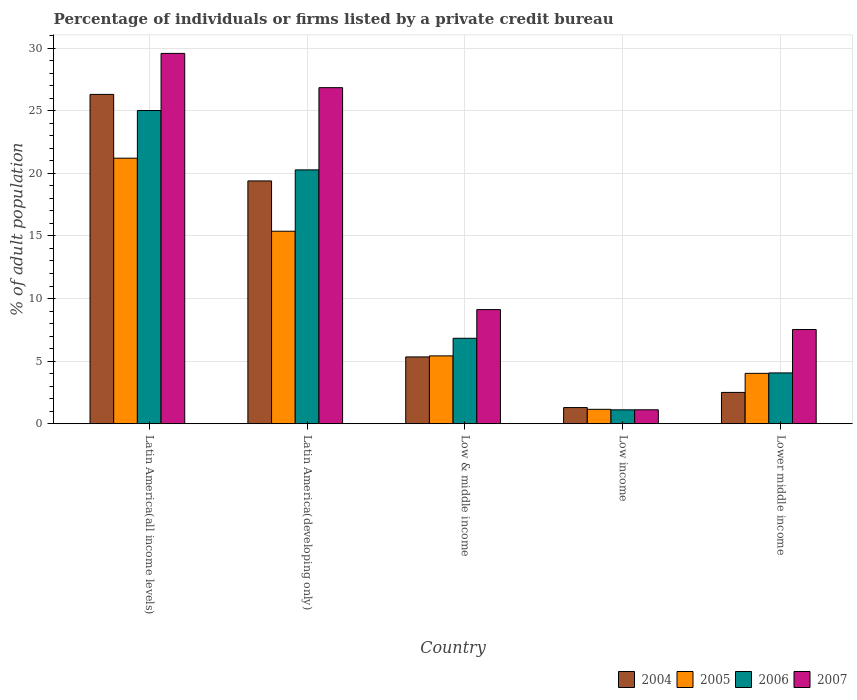How many groups of bars are there?
Your answer should be very brief. 5. Are the number of bars on each tick of the X-axis equal?
Your response must be concise. Yes. How many bars are there on the 2nd tick from the right?
Offer a very short reply. 4. What is the label of the 2nd group of bars from the left?
Keep it short and to the point. Latin America(developing only). In how many cases, is the number of bars for a given country not equal to the number of legend labels?
Make the answer very short. 0. What is the percentage of population listed by a private credit bureau in 2006 in Lower middle income?
Your answer should be compact. 4.06. Across all countries, what is the maximum percentage of population listed by a private credit bureau in 2004?
Make the answer very short. 26.3. Across all countries, what is the minimum percentage of population listed by a private credit bureau in 2007?
Keep it short and to the point. 1.11. In which country was the percentage of population listed by a private credit bureau in 2006 maximum?
Provide a short and direct response. Latin America(all income levels). In which country was the percentage of population listed by a private credit bureau in 2007 minimum?
Provide a succinct answer. Low income. What is the total percentage of population listed by a private credit bureau in 2006 in the graph?
Your response must be concise. 57.29. What is the difference between the percentage of population listed by a private credit bureau in 2007 in Latin America(developing only) and that in Lower middle income?
Provide a short and direct response. 19.32. What is the difference between the percentage of population listed by a private credit bureau in 2006 in Latin America(all income levels) and the percentage of population listed by a private credit bureau in 2005 in Latin America(developing only)?
Ensure brevity in your answer.  9.64. What is the average percentage of population listed by a private credit bureau in 2004 per country?
Provide a succinct answer. 10.97. What is the difference between the percentage of population listed by a private credit bureau of/in 2006 and percentage of population listed by a private credit bureau of/in 2007 in Low income?
Your answer should be compact. -0. In how many countries, is the percentage of population listed by a private credit bureau in 2007 greater than 18 %?
Offer a very short reply. 2. What is the ratio of the percentage of population listed by a private credit bureau in 2007 in Low income to that in Lower middle income?
Ensure brevity in your answer.  0.15. Is the percentage of population listed by a private credit bureau in 2004 in Latin America(all income levels) less than that in Low income?
Keep it short and to the point. No. Is the difference between the percentage of population listed by a private credit bureau in 2006 in Latin America(all income levels) and Latin America(developing only) greater than the difference between the percentage of population listed by a private credit bureau in 2007 in Latin America(all income levels) and Latin America(developing only)?
Ensure brevity in your answer.  Yes. What is the difference between the highest and the second highest percentage of population listed by a private credit bureau in 2007?
Offer a very short reply. -17.73. What is the difference between the highest and the lowest percentage of population listed by a private credit bureau in 2005?
Ensure brevity in your answer.  20.06. In how many countries, is the percentage of population listed by a private credit bureau in 2007 greater than the average percentage of population listed by a private credit bureau in 2007 taken over all countries?
Provide a short and direct response. 2. Is the sum of the percentage of population listed by a private credit bureau in 2005 in Latin America(all income levels) and Lower middle income greater than the maximum percentage of population listed by a private credit bureau in 2007 across all countries?
Provide a succinct answer. No. What does the 3rd bar from the left in Low income represents?
Keep it short and to the point. 2006. How many countries are there in the graph?
Provide a succinct answer. 5. What is the difference between two consecutive major ticks on the Y-axis?
Your answer should be compact. 5. Are the values on the major ticks of Y-axis written in scientific E-notation?
Give a very brief answer. No. Does the graph contain any zero values?
Provide a short and direct response. No. Does the graph contain grids?
Offer a terse response. Yes. Where does the legend appear in the graph?
Offer a terse response. Bottom right. How many legend labels are there?
Provide a succinct answer. 4. How are the legend labels stacked?
Give a very brief answer. Horizontal. What is the title of the graph?
Your answer should be very brief. Percentage of individuals or firms listed by a private credit bureau. Does "2002" appear as one of the legend labels in the graph?
Provide a short and direct response. No. What is the label or title of the X-axis?
Make the answer very short. Country. What is the label or title of the Y-axis?
Give a very brief answer. % of adult population. What is the % of adult population of 2004 in Latin America(all income levels)?
Offer a very short reply. 26.3. What is the % of adult population in 2005 in Latin America(all income levels)?
Offer a terse response. 21.21. What is the % of adult population in 2006 in Latin America(all income levels)?
Make the answer very short. 25.02. What is the % of adult population of 2007 in Latin America(all income levels)?
Provide a short and direct response. 29.58. What is the % of adult population in 2004 in Latin America(developing only)?
Provide a short and direct response. 19.39. What is the % of adult population of 2005 in Latin America(developing only)?
Make the answer very short. 15.38. What is the % of adult population in 2006 in Latin America(developing only)?
Offer a very short reply. 20.28. What is the % of adult population of 2007 in Latin America(developing only)?
Provide a short and direct response. 26.84. What is the % of adult population in 2004 in Low & middle income?
Provide a short and direct response. 5.34. What is the % of adult population of 2005 in Low & middle income?
Ensure brevity in your answer.  5.42. What is the % of adult population of 2006 in Low & middle income?
Keep it short and to the point. 6.83. What is the % of adult population of 2007 in Low & middle income?
Ensure brevity in your answer.  9.12. What is the % of adult population of 2004 in Low income?
Provide a short and direct response. 1.29. What is the % of adult population of 2005 in Low income?
Offer a terse response. 1.15. What is the % of adult population of 2006 in Low income?
Provide a succinct answer. 1.11. What is the % of adult population in 2007 in Low income?
Provide a succinct answer. 1.11. What is the % of adult population in 2004 in Lower middle income?
Offer a very short reply. 2.5. What is the % of adult population in 2005 in Lower middle income?
Keep it short and to the point. 4.03. What is the % of adult population in 2006 in Lower middle income?
Your response must be concise. 4.06. What is the % of adult population in 2007 in Lower middle income?
Provide a short and direct response. 7.53. Across all countries, what is the maximum % of adult population in 2004?
Your answer should be compact. 26.3. Across all countries, what is the maximum % of adult population of 2005?
Offer a very short reply. 21.21. Across all countries, what is the maximum % of adult population of 2006?
Offer a very short reply. 25.02. Across all countries, what is the maximum % of adult population of 2007?
Ensure brevity in your answer.  29.58. Across all countries, what is the minimum % of adult population of 2004?
Give a very brief answer. 1.29. Across all countries, what is the minimum % of adult population of 2005?
Offer a terse response. 1.15. Across all countries, what is the minimum % of adult population of 2006?
Make the answer very short. 1.11. Across all countries, what is the minimum % of adult population of 2007?
Give a very brief answer. 1.11. What is the total % of adult population of 2004 in the graph?
Offer a very short reply. 54.83. What is the total % of adult population in 2005 in the graph?
Your answer should be compact. 47.18. What is the total % of adult population in 2006 in the graph?
Ensure brevity in your answer.  57.29. What is the total % of adult population in 2007 in the graph?
Offer a terse response. 74.18. What is the difference between the % of adult population in 2004 in Latin America(all income levels) and that in Latin America(developing only)?
Provide a succinct answer. 6.91. What is the difference between the % of adult population in 2005 in Latin America(all income levels) and that in Latin America(developing only)?
Offer a very short reply. 5.83. What is the difference between the % of adult population of 2006 in Latin America(all income levels) and that in Latin America(developing only)?
Provide a short and direct response. 4.74. What is the difference between the % of adult population in 2007 in Latin America(all income levels) and that in Latin America(developing only)?
Offer a very short reply. 2.74. What is the difference between the % of adult population of 2004 in Latin America(all income levels) and that in Low & middle income?
Your response must be concise. 20.97. What is the difference between the % of adult population in 2005 in Latin America(all income levels) and that in Low & middle income?
Provide a short and direct response. 15.79. What is the difference between the % of adult population of 2006 in Latin America(all income levels) and that in Low & middle income?
Offer a very short reply. 18.19. What is the difference between the % of adult population of 2007 in Latin America(all income levels) and that in Low & middle income?
Ensure brevity in your answer.  20.46. What is the difference between the % of adult population of 2004 in Latin America(all income levels) and that in Low income?
Offer a very short reply. 25.01. What is the difference between the % of adult population of 2005 in Latin America(all income levels) and that in Low income?
Your answer should be compact. 20.06. What is the difference between the % of adult population of 2006 in Latin America(all income levels) and that in Low income?
Offer a very short reply. 23.91. What is the difference between the % of adult population of 2007 in Latin America(all income levels) and that in Low income?
Keep it short and to the point. 28.47. What is the difference between the % of adult population of 2004 in Latin America(all income levels) and that in Lower middle income?
Your answer should be compact. 23.8. What is the difference between the % of adult population of 2005 in Latin America(all income levels) and that in Lower middle income?
Ensure brevity in your answer.  17.19. What is the difference between the % of adult population in 2006 in Latin America(all income levels) and that in Lower middle income?
Keep it short and to the point. 20.96. What is the difference between the % of adult population in 2007 in Latin America(all income levels) and that in Lower middle income?
Keep it short and to the point. 22.05. What is the difference between the % of adult population in 2004 in Latin America(developing only) and that in Low & middle income?
Make the answer very short. 14.06. What is the difference between the % of adult population in 2005 in Latin America(developing only) and that in Low & middle income?
Provide a succinct answer. 9.96. What is the difference between the % of adult population in 2006 in Latin America(developing only) and that in Low & middle income?
Your answer should be compact. 13.45. What is the difference between the % of adult population in 2007 in Latin America(developing only) and that in Low & middle income?
Keep it short and to the point. 17.73. What is the difference between the % of adult population in 2004 in Latin America(developing only) and that in Low income?
Provide a short and direct response. 18.1. What is the difference between the % of adult population in 2005 in Latin America(developing only) and that in Low income?
Offer a terse response. 14.22. What is the difference between the % of adult population in 2006 in Latin America(developing only) and that in Low income?
Ensure brevity in your answer.  19.17. What is the difference between the % of adult population of 2007 in Latin America(developing only) and that in Low income?
Ensure brevity in your answer.  25.73. What is the difference between the % of adult population in 2004 in Latin America(developing only) and that in Lower middle income?
Provide a succinct answer. 16.89. What is the difference between the % of adult population of 2005 in Latin America(developing only) and that in Lower middle income?
Give a very brief answer. 11.35. What is the difference between the % of adult population of 2006 in Latin America(developing only) and that in Lower middle income?
Offer a very short reply. 16.22. What is the difference between the % of adult population in 2007 in Latin America(developing only) and that in Lower middle income?
Your response must be concise. 19.32. What is the difference between the % of adult population in 2004 in Low & middle income and that in Low income?
Your response must be concise. 4.04. What is the difference between the % of adult population in 2005 in Low & middle income and that in Low income?
Provide a succinct answer. 4.27. What is the difference between the % of adult population in 2006 in Low & middle income and that in Low income?
Provide a short and direct response. 5.72. What is the difference between the % of adult population of 2007 in Low & middle income and that in Low income?
Offer a very short reply. 8. What is the difference between the % of adult population in 2004 in Low & middle income and that in Lower middle income?
Ensure brevity in your answer.  2.83. What is the difference between the % of adult population of 2005 in Low & middle income and that in Lower middle income?
Your answer should be very brief. 1.39. What is the difference between the % of adult population of 2006 in Low & middle income and that in Lower middle income?
Offer a very short reply. 2.77. What is the difference between the % of adult population of 2007 in Low & middle income and that in Lower middle income?
Your response must be concise. 1.59. What is the difference between the % of adult population of 2004 in Low income and that in Lower middle income?
Keep it short and to the point. -1.21. What is the difference between the % of adult population of 2005 in Low income and that in Lower middle income?
Offer a terse response. -2.87. What is the difference between the % of adult population of 2006 in Low income and that in Lower middle income?
Provide a short and direct response. -2.95. What is the difference between the % of adult population of 2007 in Low income and that in Lower middle income?
Provide a succinct answer. -6.41. What is the difference between the % of adult population of 2004 in Latin America(all income levels) and the % of adult population of 2005 in Latin America(developing only)?
Your response must be concise. 10.93. What is the difference between the % of adult population of 2004 in Latin America(all income levels) and the % of adult population of 2006 in Latin America(developing only)?
Offer a very short reply. 6.03. What is the difference between the % of adult population of 2004 in Latin America(all income levels) and the % of adult population of 2007 in Latin America(developing only)?
Provide a succinct answer. -0.54. What is the difference between the % of adult population of 2005 in Latin America(all income levels) and the % of adult population of 2006 in Latin America(developing only)?
Your answer should be very brief. 0.93. What is the difference between the % of adult population in 2005 in Latin America(all income levels) and the % of adult population in 2007 in Latin America(developing only)?
Offer a very short reply. -5.63. What is the difference between the % of adult population of 2006 in Latin America(all income levels) and the % of adult population of 2007 in Latin America(developing only)?
Provide a short and direct response. -1.83. What is the difference between the % of adult population of 2004 in Latin America(all income levels) and the % of adult population of 2005 in Low & middle income?
Offer a terse response. 20.89. What is the difference between the % of adult population of 2004 in Latin America(all income levels) and the % of adult population of 2006 in Low & middle income?
Provide a succinct answer. 19.48. What is the difference between the % of adult population of 2004 in Latin America(all income levels) and the % of adult population of 2007 in Low & middle income?
Offer a terse response. 17.19. What is the difference between the % of adult population of 2005 in Latin America(all income levels) and the % of adult population of 2006 in Low & middle income?
Your answer should be very brief. 14.38. What is the difference between the % of adult population in 2005 in Latin America(all income levels) and the % of adult population in 2007 in Low & middle income?
Your answer should be very brief. 12.09. What is the difference between the % of adult population in 2006 in Latin America(all income levels) and the % of adult population in 2007 in Low & middle income?
Make the answer very short. 15.9. What is the difference between the % of adult population in 2004 in Latin America(all income levels) and the % of adult population in 2005 in Low income?
Ensure brevity in your answer.  25.15. What is the difference between the % of adult population in 2004 in Latin America(all income levels) and the % of adult population in 2006 in Low income?
Ensure brevity in your answer.  25.19. What is the difference between the % of adult population in 2004 in Latin America(all income levels) and the % of adult population in 2007 in Low income?
Your response must be concise. 25.19. What is the difference between the % of adult population of 2005 in Latin America(all income levels) and the % of adult population of 2006 in Low income?
Provide a succinct answer. 20.1. What is the difference between the % of adult population of 2005 in Latin America(all income levels) and the % of adult population of 2007 in Low income?
Ensure brevity in your answer.  20.1. What is the difference between the % of adult population of 2006 in Latin America(all income levels) and the % of adult population of 2007 in Low income?
Offer a terse response. 23.9. What is the difference between the % of adult population in 2004 in Latin America(all income levels) and the % of adult population in 2005 in Lower middle income?
Provide a succinct answer. 22.28. What is the difference between the % of adult population of 2004 in Latin America(all income levels) and the % of adult population of 2006 in Lower middle income?
Your response must be concise. 22.25. What is the difference between the % of adult population of 2004 in Latin America(all income levels) and the % of adult population of 2007 in Lower middle income?
Your response must be concise. 18.78. What is the difference between the % of adult population of 2005 in Latin America(all income levels) and the % of adult population of 2006 in Lower middle income?
Provide a short and direct response. 17.15. What is the difference between the % of adult population of 2005 in Latin America(all income levels) and the % of adult population of 2007 in Lower middle income?
Your answer should be compact. 13.69. What is the difference between the % of adult population in 2006 in Latin America(all income levels) and the % of adult population in 2007 in Lower middle income?
Offer a very short reply. 17.49. What is the difference between the % of adult population in 2004 in Latin America(developing only) and the % of adult population in 2005 in Low & middle income?
Your answer should be very brief. 13.97. What is the difference between the % of adult population of 2004 in Latin America(developing only) and the % of adult population of 2006 in Low & middle income?
Your answer should be compact. 12.57. What is the difference between the % of adult population in 2004 in Latin America(developing only) and the % of adult population in 2007 in Low & middle income?
Your answer should be very brief. 10.28. What is the difference between the % of adult population in 2005 in Latin America(developing only) and the % of adult population in 2006 in Low & middle income?
Your answer should be compact. 8.55. What is the difference between the % of adult population in 2005 in Latin America(developing only) and the % of adult population in 2007 in Low & middle income?
Ensure brevity in your answer.  6.26. What is the difference between the % of adult population in 2006 in Latin America(developing only) and the % of adult population in 2007 in Low & middle income?
Make the answer very short. 11.16. What is the difference between the % of adult population of 2004 in Latin America(developing only) and the % of adult population of 2005 in Low income?
Offer a terse response. 18.24. What is the difference between the % of adult population in 2004 in Latin America(developing only) and the % of adult population in 2006 in Low income?
Your answer should be compact. 18.28. What is the difference between the % of adult population of 2004 in Latin America(developing only) and the % of adult population of 2007 in Low income?
Make the answer very short. 18.28. What is the difference between the % of adult population in 2005 in Latin America(developing only) and the % of adult population in 2006 in Low income?
Make the answer very short. 14.27. What is the difference between the % of adult population of 2005 in Latin America(developing only) and the % of adult population of 2007 in Low income?
Your response must be concise. 14.26. What is the difference between the % of adult population in 2006 in Latin America(developing only) and the % of adult population in 2007 in Low income?
Ensure brevity in your answer.  19.16. What is the difference between the % of adult population in 2004 in Latin America(developing only) and the % of adult population in 2005 in Lower middle income?
Provide a short and direct response. 15.37. What is the difference between the % of adult population in 2004 in Latin America(developing only) and the % of adult population in 2006 in Lower middle income?
Make the answer very short. 15.33. What is the difference between the % of adult population in 2004 in Latin America(developing only) and the % of adult population in 2007 in Lower middle income?
Make the answer very short. 11.87. What is the difference between the % of adult population in 2005 in Latin America(developing only) and the % of adult population in 2006 in Lower middle income?
Provide a succinct answer. 11.32. What is the difference between the % of adult population in 2005 in Latin America(developing only) and the % of adult population in 2007 in Lower middle income?
Offer a very short reply. 7.85. What is the difference between the % of adult population of 2006 in Latin America(developing only) and the % of adult population of 2007 in Lower middle income?
Your answer should be compact. 12.75. What is the difference between the % of adult population in 2004 in Low & middle income and the % of adult population in 2005 in Low income?
Provide a succinct answer. 4.18. What is the difference between the % of adult population of 2004 in Low & middle income and the % of adult population of 2006 in Low income?
Provide a short and direct response. 4.22. What is the difference between the % of adult population in 2004 in Low & middle income and the % of adult population in 2007 in Low income?
Your answer should be compact. 4.22. What is the difference between the % of adult population in 2005 in Low & middle income and the % of adult population in 2006 in Low income?
Offer a very short reply. 4.31. What is the difference between the % of adult population of 2005 in Low & middle income and the % of adult population of 2007 in Low income?
Your answer should be compact. 4.3. What is the difference between the % of adult population of 2006 in Low & middle income and the % of adult population of 2007 in Low income?
Your response must be concise. 5.71. What is the difference between the % of adult population in 2004 in Low & middle income and the % of adult population in 2005 in Lower middle income?
Provide a short and direct response. 1.31. What is the difference between the % of adult population in 2004 in Low & middle income and the % of adult population in 2006 in Lower middle income?
Offer a terse response. 1.28. What is the difference between the % of adult population in 2004 in Low & middle income and the % of adult population in 2007 in Lower middle income?
Offer a terse response. -2.19. What is the difference between the % of adult population of 2005 in Low & middle income and the % of adult population of 2006 in Lower middle income?
Your answer should be compact. 1.36. What is the difference between the % of adult population of 2005 in Low & middle income and the % of adult population of 2007 in Lower middle income?
Make the answer very short. -2.11. What is the difference between the % of adult population in 2006 in Low & middle income and the % of adult population in 2007 in Lower middle income?
Your response must be concise. -0.7. What is the difference between the % of adult population of 2004 in Low income and the % of adult population of 2005 in Lower middle income?
Your answer should be compact. -2.73. What is the difference between the % of adult population in 2004 in Low income and the % of adult population in 2006 in Lower middle income?
Your answer should be very brief. -2.77. What is the difference between the % of adult population in 2004 in Low income and the % of adult population in 2007 in Lower middle income?
Provide a succinct answer. -6.23. What is the difference between the % of adult population of 2005 in Low income and the % of adult population of 2006 in Lower middle income?
Your answer should be compact. -2.91. What is the difference between the % of adult population in 2005 in Low income and the % of adult population in 2007 in Lower middle income?
Your answer should be compact. -6.37. What is the difference between the % of adult population in 2006 in Low income and the % of adult population in 2007 in Lower middle income?
Give a very brief answer. -6.41. What is the average % of adult population in 2004 per country?
Provide a succinct answer. 10.97. What is the average % of adult population of 2005 per country?
Your response must be concise. 9.44. What is the average % of adult population in 2006 per country?
Provide a short and direct response. 11.46. What is the average % of adult population of 2007 per country?
Offer a very short reply. 14.84. What is the difference between the % of adult population of 2004 and % of adult population of 2005 in Latin America(all income levels)?
Provide a succinct answer. 5.09. What is the difference between the % of adult population in 2004 and % of adult population in 2006 in Latin America(all income levels)?
Provide a succinct answer. 1.29. What is the difference between the % of adult population in 2004 and % of adult population in 2007 in Latin America(all income levels)?
Your response must be concise. -3.27. What is the difference between the % of adult population of 2005 and % of adult population of 2006 in Latin America(all income levels)?
Keep it short and to the point. -3.81. What is the difference between the % of adult population in 2005 and % of adult population in 2007 in Latin America(all income levels)?
Keep it short and to the point. -8.37. What is the difference between the % of adult population of 2006 and % of adult population of 2007 in Latin America(all income levels)?
Your response must be concise. -4.56. What is the difference between the % of adult population in 2004 and % of adult population in 2005 in Latin America(developing only)?
Offer a very short reply. 4.02. What is the difference between the % of adult population of 2004 and % of adult population of 2006 in Latin America(developing only)?
Your answer should be very brief. -0.88. What is the difference between the % of adult population of 2004 and % of adult population of 2007 in Latin America(developing only)?
Your response must be concise. -7.45. What is the difference between the % of adult population of 2005 and % of adult population of 2007 in Latin America(developing only)?
Your answer should be very brief. -11.47. What is the difference between the % of adult population in 2006 and % of adult population in 2007 in Latin America(developing only)?
Provide a succinct answer. -6.57. What is the difference between the % of adult population of 2004 and % of adult population of 2005 in Low & middle income?
Make the answer very short. -0.08. What is the difference between the % of adult population in 2004 and % of adult population in 2006 in Low & middle income?
Provide a short and direct response. -1.49. What is the difference between the % of adult population of 2004 and % of adult population of 2007 in Low & middle income?
Your answer should be very brief. -3.78. What is the difference between the % of adult population in 2005 and % of adult population in 2006 in Low & middle income?
Offer a terse response. -1.41. What is the difference between the % of adult population in 2005 and % of adult population in 2007 in Low & middle income?
Provide a succinct answer. -3.7. What is the difference between the % of adult population in 2006 and % of adult population in 2007 in Low & middle income?
Provide a short and direct response. -2.29. What is the difference between the % of adult population of 2004 and % of adult population of 2005 in Low income?
Make the answer very short. 0.14. What is the difference between the % of adult population of 2004 and % of adult population of 2006 in Low income?
Your answer should be very brief. 0.18. What is the difference between the % of adult population of 2004 and % of adult population of 2007 in Low income?
Your response must be concise. 0.18. What is the difference between the % of adult population in 2005 and % of adult population in 2006 in Low income?
Keep it short and to the point. 0.04. What is the difference between the % of adult population in 2005 and % of adult population in 2007 in Low income?
Ensure brevity in your answer.  0.04. What is the difference between the % of adult population of 2006 and % of adult population of 2007 in Low income?
Make the answer very short. -0. What is the difference between the % of adult population in 2004 and % of adult population in 2005 in Lower middle income?
Make the answer very short. -1.52. What is the difference between the % of adult population of 2004 and % of adult population of 2006 in Lower middle income?
Offer a very short reply. -1.56. What is the difference between the % of adult population in 2004 and % of adult population in 2007 in Lower middle income?
Ensure brevity in your answer.  -5.02. What is the difference between the % of adult population of 2005 and % of adult population of 2006 in Lower middle income?
Offer a very short reply. -0.03. What is the difference between the % of adult population in 2006 and % of adult population in 2007 in Lower middle income?
Keep it short and to the point. -3.47. What is the ratio of the % of adult population in 2004 in Latin America(all income levels) to that in Latin America(developing only)?
Ensure brevity in your answer.  1.36. What is the ratio of the % of adult population of 2005 in Latin America(all income levels) to that in Latin America(developing only)?
Your answer should be compact. 1.38. What is the ratio of the % of adult population of 2006 in Latin America(all income levels) to that in Latin America(developing only)?
Offer a terse response. 1.23. What is the ratio of the % of adult population of 2007 in Latin America(all income levels) to that in Latin America(developing only)?
Give a very brief answer. 1.1. What is the ratio of the % of adult population of 2004 in Latin America(all income levels) to that in Low & middle income?
Provide a short and direct response. 4.93. What is the ratio of the % of adult population in 2005 in Latin America(all income levels) to that in Low & middle income?
Provide a succinct answer. 3.91. What is the ratio of the % of adult population of 2006 in Latin America(all income levels) to that in Low & middle income?
Ensure brevity in your answer.  3.66. What is the ratio of the % of adult population in 2007 in Latin America(all income levels) to that in Low & middle income?
Provide a short and direct response. 3.24. What is the ratio of the % of adult population in 2004 in Latin America(all income levels) to that in Low income?
Your answer should be compact. 20.37. What is the ratio of the % of adult population of 2005 in Latin America(all income levels) to that in Low income?
Provide a succinct answer. 18.41. What is the ratio of the % of adult population in 2006 in Latin America(all income levels) to that in Low income?
Your answer should be compact. 22.52. What is the ratio of the % of adult population in 2007 in Latin America(all income levels) to that in Low income?
Keep it short and to the point. 26.55. What is the ratio of the % of adult population of 2004 in Latin America(all income levels) to that in Lower middle income?
Give a very brief answer. 10.51. What is the ratio of the % of adult population of 2005 in Latin America(all income levels) to that in Lower middle income?
Make the answer very short. 5.27. What is the ratio of the % of adult population in 2006 in Latin America(all income levels) to that in Lower middle income?
Your response must be concise. 6.16. What is the ratio of the % of adult population of 2007 in Latin America(all income levels) to that in Lower middle income?
Your answer should be compact. 3.93. What is the ratio of the % of adult population in 2004 in Latin America(developing only) to that in Low & middle income?
Provide a short and direct response. 3.63. What is the ratio of the % of adult population of 2005 in Latin America(developing only) to that in Low & middle income?
Your response must be concise. 2.84. What is the ratio of the % of adult population of 2006 in Latin America(developing only) to that in Low & middle income?
Your response must be concise. 2.97. What is the ratio of the % of adult population in 2007 in Latin America(developing only) to that in Low & middle income?
Give a very brief answer. 2.94. What is the ratio of the % of adult population of 2004 in Latin America(developing only) to that in Low income?
Offer a very short reply. 15.01. What is the ratio of the % of adult population in 2005 in Latin America(developing only) to that in Low income?
Offer a very short reply. 13.35. What is the ratio of the % of adult population in 2006 in Latin America(developing only) to that in Low income?
Give a very brief answer. 18.26. What is the ratio of the % of adult population in 2007 in Latin America(developing only) to that in Low income?
Your response must be concise. 24.09. What is the ratio of the % of adult population of 2004 in Latin America(developing only) to that in Lower middle income?
Keep it short and to the point. 7.75. What is the ratio of the % of adult population of 2005 in Latin America(developing only) to that in Lower middle income?
Provide a short and direct response. 3.82. What is the ratio of the % of adult population of 2006 in Latin America(developing only) to that in Lower middle income?
Keep it short and to the point. 5. What is the ratio of the % of adult population in 2007 in Latin America(developing only) to that in Lower middle income?
Provide a short and direct response. 3.57. What is the ratio of the % of adult population of 2004 in Low & middle income to that in Low income?
Your response must be concise. 4.13. What is the ratio of the % of adult population in 2005 in Low & middle income to that in Low income?
Your answer should be very brief. 4.7. What is the ratio of the % of adult population of 2006 in Low & middle income to that in Low income?
Make the answer very short. 6.15. What is the ratio of the % of adult population in 2007 in Low & middle income to that in Low income?
Your response must be concise. 8.18. What is the ratio of the % of adult population in 2004 in Low & middle income to that in Lower middle income?
Your answer should be compact. 2.13. What is the ratio of the % of adult population in 2005 in Low & middle income to that in Lower middle income?
Your answer should be very brief. 1.35. What is the ratio of the % of adult population of 2006 in Low & middle income to that in Lower middle income?
Offer a very short reply. 1.68. What is the ratio of the % of adult population of 2007 in Low & middle income to that in Lower middle income?
Your response must be concise. 1.21. What is the ratio of the % of adult population in 2004 in Low income to that in Lower middle income?
Provide a succinct answer. 0.52. What is the ratio of the % of adult population of 2005 in Low income to that in Lower middle income?
Give a very brief answer. 0.29. What is the ratio of the % of adult population of 2006 in Low income to that in Lower middle income?
Offer a terse response. 0.27. What is the ratio of the % of adult population of 2007 in Low income to that in Lower middle income?
Provide a succinct answer. 0.15. What is the difference between the highest and the second highest % of adult population in 2004?
Make the answer very short. 6.91. What is the difference between the highest and the second highest % of adult population of 2005?
Give a very brief answer. 5.83. What is the difference between the highest and the second highest % of adult population of 2006?
Make the answer very short. 4.74. What is the difference between the highest and the second highest % of adult population of 2007?
Ensure brevity in your answer.  2.74. What is the difference between the highest and the lowest % of adult population of 2004?
Give a very brief answer. 25.01. What is the difference between the highest and the lowest % of adult population of 2005?
Provide a succinct answer. 20.06. What is the difference between the highest and the lowest % of adult population in 2006?
Provide a succinct answer. 23.91. What is the difference between the highest and the lowest % of adult population in 2007?
Ensure brevity in your answer.  28.47. 